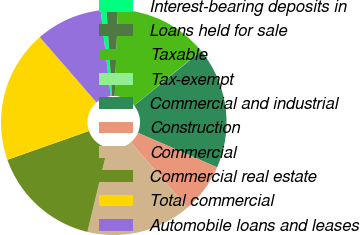<chart> <loc_0><loc_0><loc_500><loc_500><pie_chart><fcel>Interest-bearing deposits in<fcel>Loans held for sale<fcel>Taxable<fcel>Tax-exempt<fcel>Commercial and industrial<fcel>Construction<fcel>Commercial<fcel>Commercial real estate<fcel>Total commercial<fcel>Automobile loans and leases<nl><fcel>0.83%<fcel>1.62%<fcel>13.48%<fcel>0.04%<fcel>17.43%<fcel>7.15%<fcel>15.06%<fcel>15.85%<fcel>19.01%<fcel>9.53%<nl></chart> 